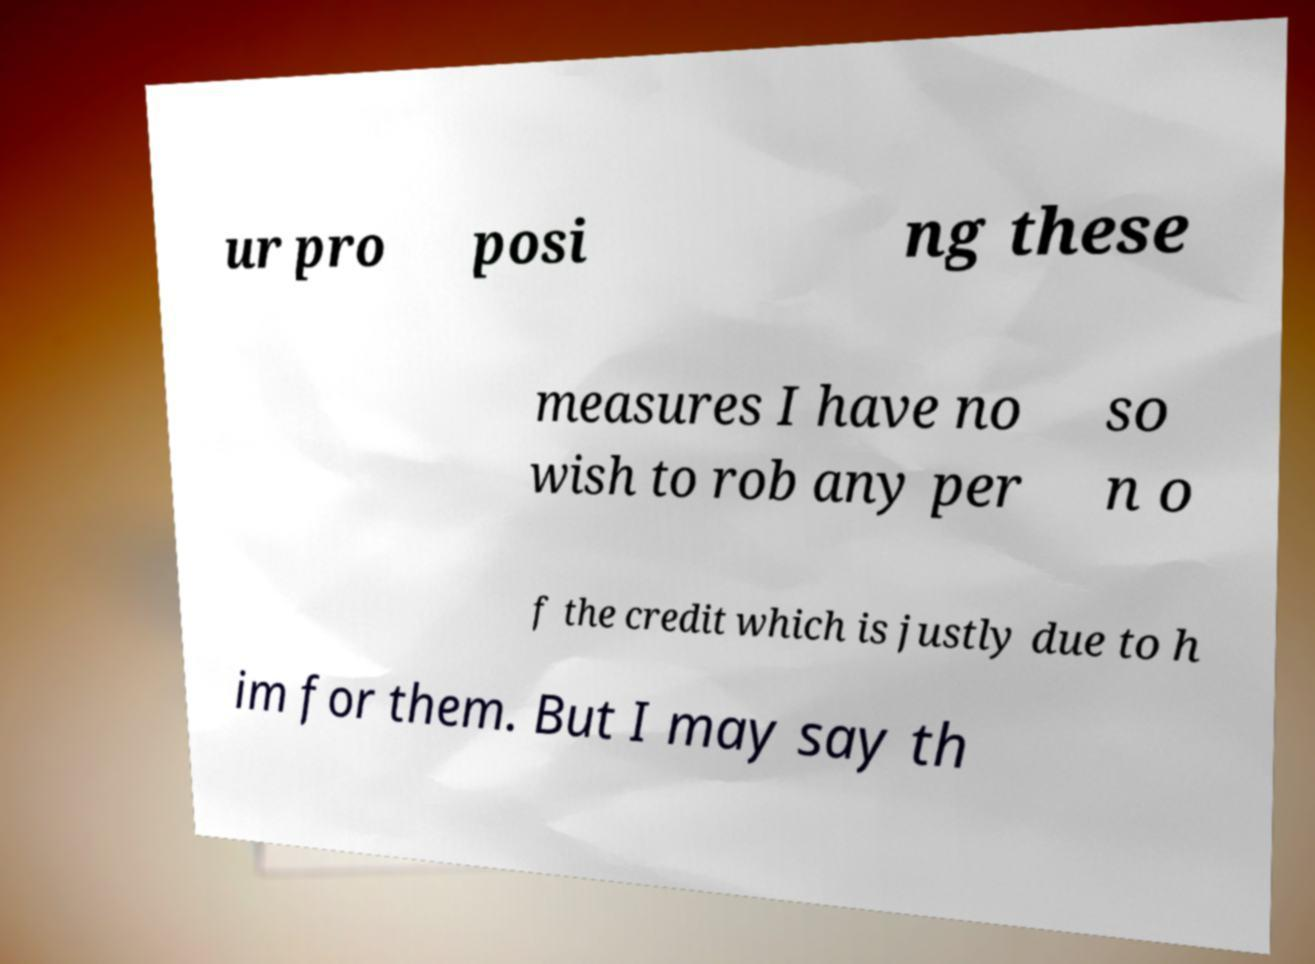Can you accurately transcribe the text from the provided image for me? ur pro posi ng these measures I have no wish to rob any per so n o f the credit which is justly due to h im for them. But I may say th 